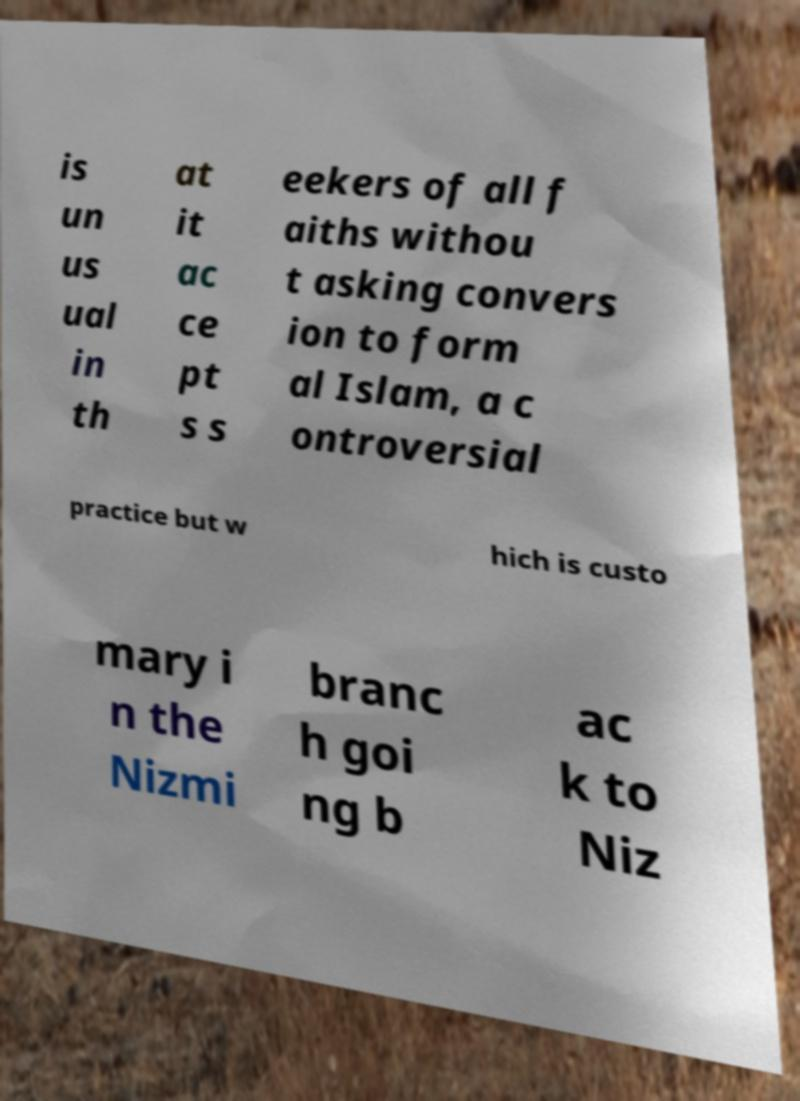Please read and relay the text visible in this image. What does it say? is un us ual in th at it ac ce pt s s eekers of all f aiths withou t asking convers ion to form al Islam, a c ontroversial practice but w hich is custo mary i n the Nizmi branc h goi ng b ac k to Niz 